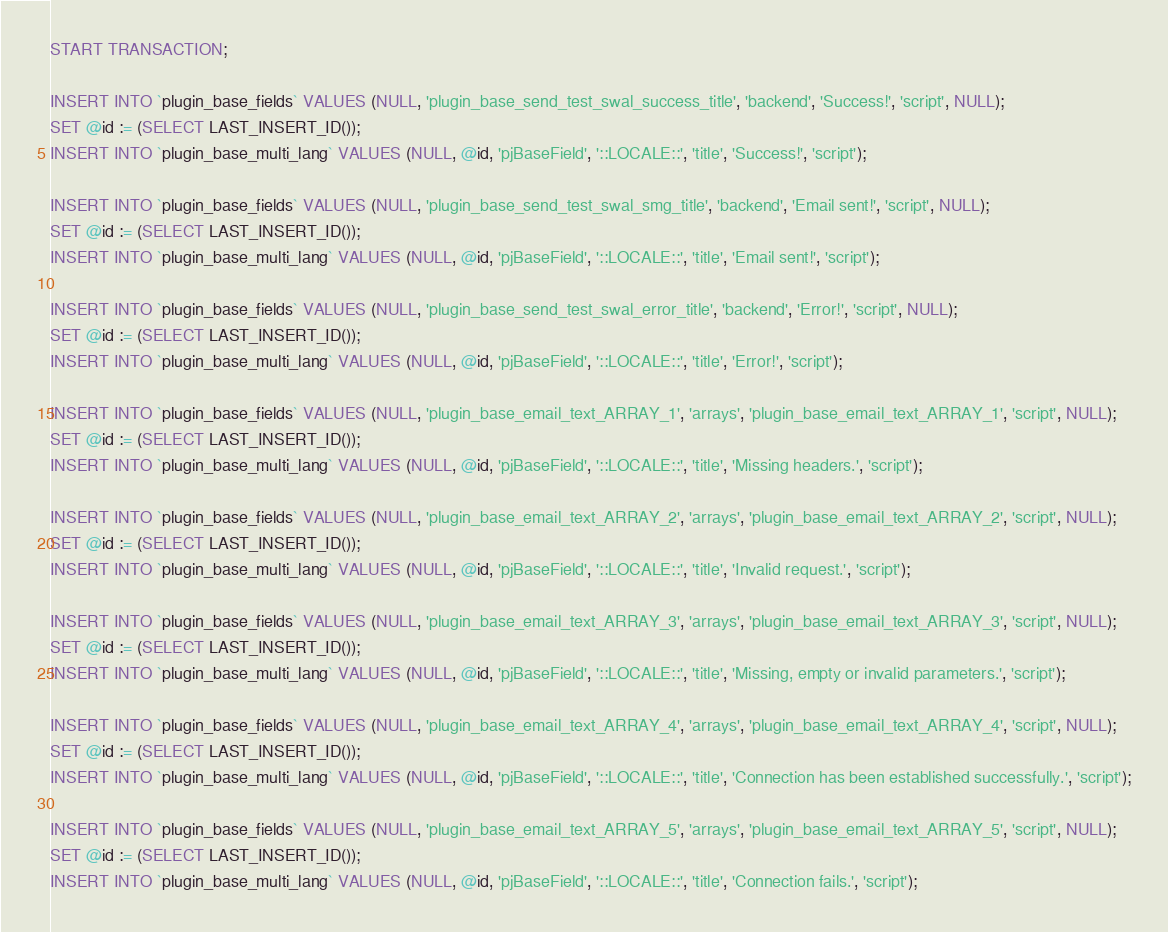Convert code to text. <code><loc_0><loc_0><loc_500><loc_500><_SQL_>
START TRANSACTION;

INSERT INTO `plugin_base_fields` VALUES (NULL, 'plugin_base_send_test_swal_success_title', 'backend', 'Success!', 'script', NULL);
SET @id := (SELECT LAST_INSERT_ID());
INSERT INTO `plugin_base_multi_lang` VALUES (NULL, @id, 'pjBaseField', '::LOCALE::', 'title', 'Success!', 'script');

INSERT INTO `plugin_base_fields` VALUES (NULL, 'plugin_base_send_test_swal_smg_title', 'backend', 'Email sent!', 'script', NULL);
SET @id := (SELECT LAST_INSERT_ID());
INSERT INTO `plugin_base_multi_lang` VALUES (NULL, @id, 'pjBaseField', '::LOCALE::', 'title', 'Email sent!', 'script');

INSERT INTO `plugin_base_fields` VALUES (NULL, 'plugin_base_send_test_swal_error_title', 'backend', 'Error!', 'script', NULL);
SET @id := (SELECT LAST_INSERT_ID());
INSERT INTO `plugin_base_multi_lang` VALUES (NULL, @id, 'pjBaseField', '::LOCALE::', 'title', 'Error!', 'script');

INSERT INTO `plugin_base_fields` VALUES (NULL, 'plugin_base_email_text_ARRAY_1', 'arrays', 'plugin_base_email_text_ARRAY_1', 'script', NULL);
SET @id := (SELECT LAST_INSERT_ID());
INSERT INTO `plugin_base_multi_lang` VALUES (NULL, @id, 'pjBaseField', '::LOCALE::', 'title', 'Missing headers.', 'script');

INSERT INTO `plugin_base_fields` VALUES (NULL, 'plugin_base_email_text_ARRAY_2', 'arrays', 'plugin_base_email_text_ARRAY_2', 'script', NULL);
SET @id := (SELECT LAST_INSERT_ID());
INSERT INTO `plugin_base_multi_lang` VALUES (NULL, @id, 'pjBaseField', '::LOCALE::', 'title', 'Invalid request.', 'script');

INSERT INTO `plugin_base_fields` VALUES (NULL, 'plugin_base_email_text_ARRAY_3', 'arrays', 'plugin_base_email_text_ARRAY_3', 'script', NULL);
SET @id := (SELECT LAST_INSERT_ID());
INSERT INTO `plugin_base_multi_lang` VALUES (NULL, @id, 'pjBaseField', '::LOCALE::', 'title', 'Missing, empty or invalid parameters.', 'script');

INSERT INTO `plugin_base_fields` VALUES (NULL, 'plugin_base_email_text_ARRAY_4', 'arrays', 'plugin_base_email_text_ARRAY_4', 'script', NULL);
SET @id := (SELECT LAST_INSERT_ID());
INSERT INTO `plugin_base_multi_lang` VALUES (NULL, @id, 'pjBaseField', '::LOCALE::', 'title', 'Connection has been established successfully.', 'script');

INSERT INTO `plugin_base_fields` VALUES (NULL, 'plugin_base_email_text_ARRAY_5', 'arrays', 'plugin_base_email_text_ARRAY_5', 'script', NULL);
SET @id := (SELECT LAST_INSERT_ID());
INSERT INTO `plugin_base_multi_lang` VALUES (NULL, @id, 'pjBaseField', '::LOCALE::', 'title', 'Connection fails.', 'script');
</code> 